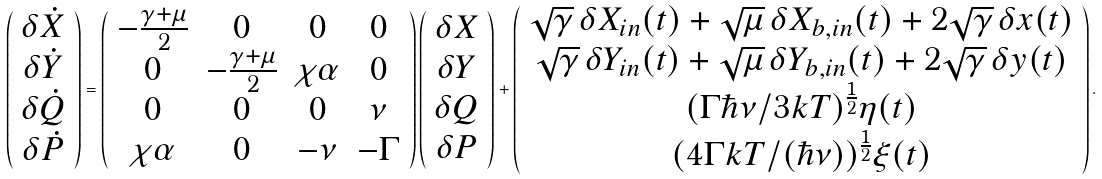Convert formula to latex. <formula><loc_0><loc_0><loc_500><loc_500>\left ( \begin{array} { c } \delta \dot { X } \\ \delta \dot { Y } \\ \delta \dot { Q } \\ \delta \dot { P } \end{array} \right ) = \left ( \begin{array} { c c c c } - \frac { \gamma + \mu } { 2 } & 0 & 0 & 0 \\ 0 & - \frac { \gamma + \mu } { 2 } & \chi \alpha & 0 \\ 0 & 0 & 0 & \nu \\ \chi \alpha & 0 & - \nu & - \Gamma \end{array} \right ) \left ( \begin{array} { c } \delta X \\ \delta Y \\ \delta Q \\ \delta P \end{array} \right ) + \left ( \begin{array} { c } \sqrt { \gamma } \, \delta X _ { i n } ( t ) + \sqrt { \mu } \, \delta X _ { b , i n } ( t ) + 2 \sqrt { \gamma } \, \delta x ( t ) \\ \sqrt { \gamma } \, \delta Y _ { i n } ( t ) + \sqrt { \mu } \, \delta Y _ { b , i n } ( t ) + 2 \sqrt { \gamma } \, \delta y ( t ) \\ ( \Gamma \hbar { \nu } / 3 k T ) ^ { \frac { 1 } { 2 } } \eta ( t ) \\ ( 4 \Gamma k T / ( \hbar { \nu } ) ) ^ { \frac { 1 } { 2 } } \xi ( t ) \end{array} \right ) .</formula> 